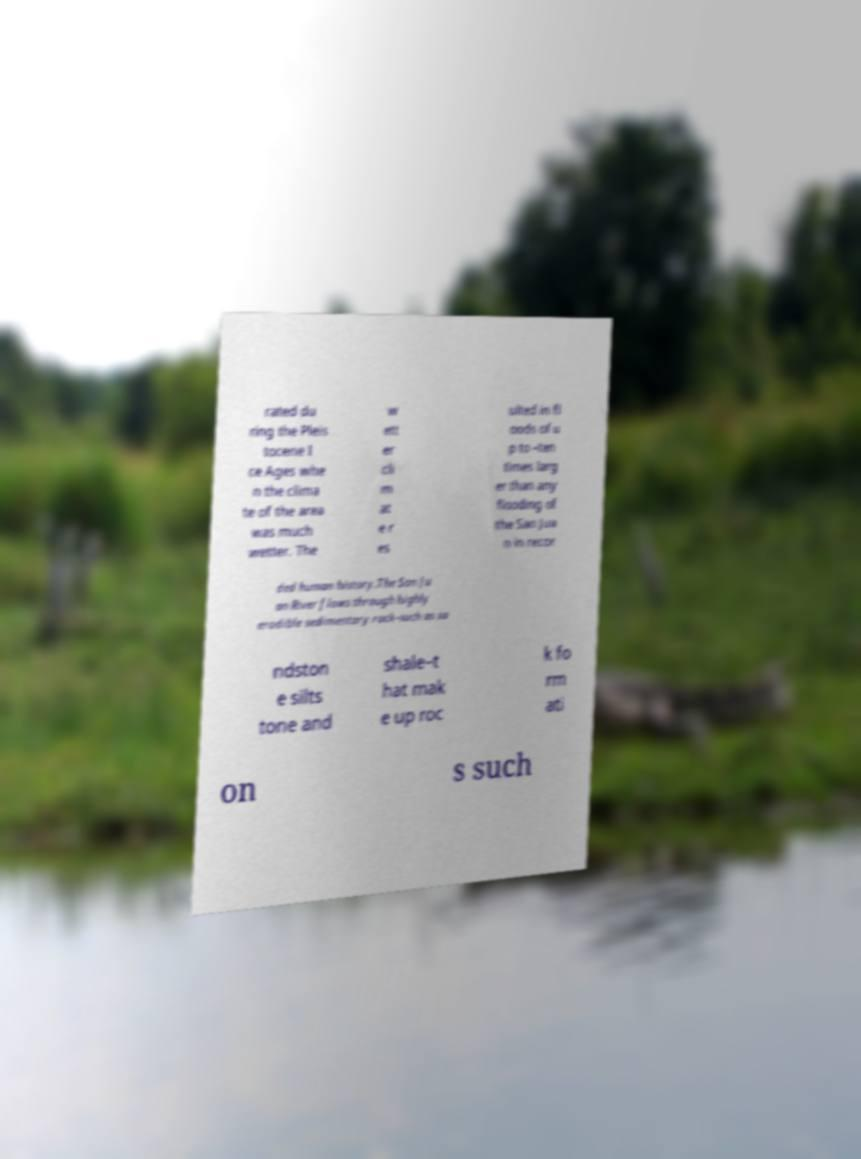There's text embedded in this image that I need extracted. Can you transcribe it verbatim? rated du ring the Pleis tocene I ce Ages whe n the clima te of the area was much wetter. The w ett er cli m at e r es ulted in fl oods of u p to –ten times larg er than any flooding of the San Jua n in recor ded human history.The San Ju an River flows through highly erodible sedimentary rock–such as sa ndston e silts tone and shale–t hat mak e up roc k fo rm ati on s such 